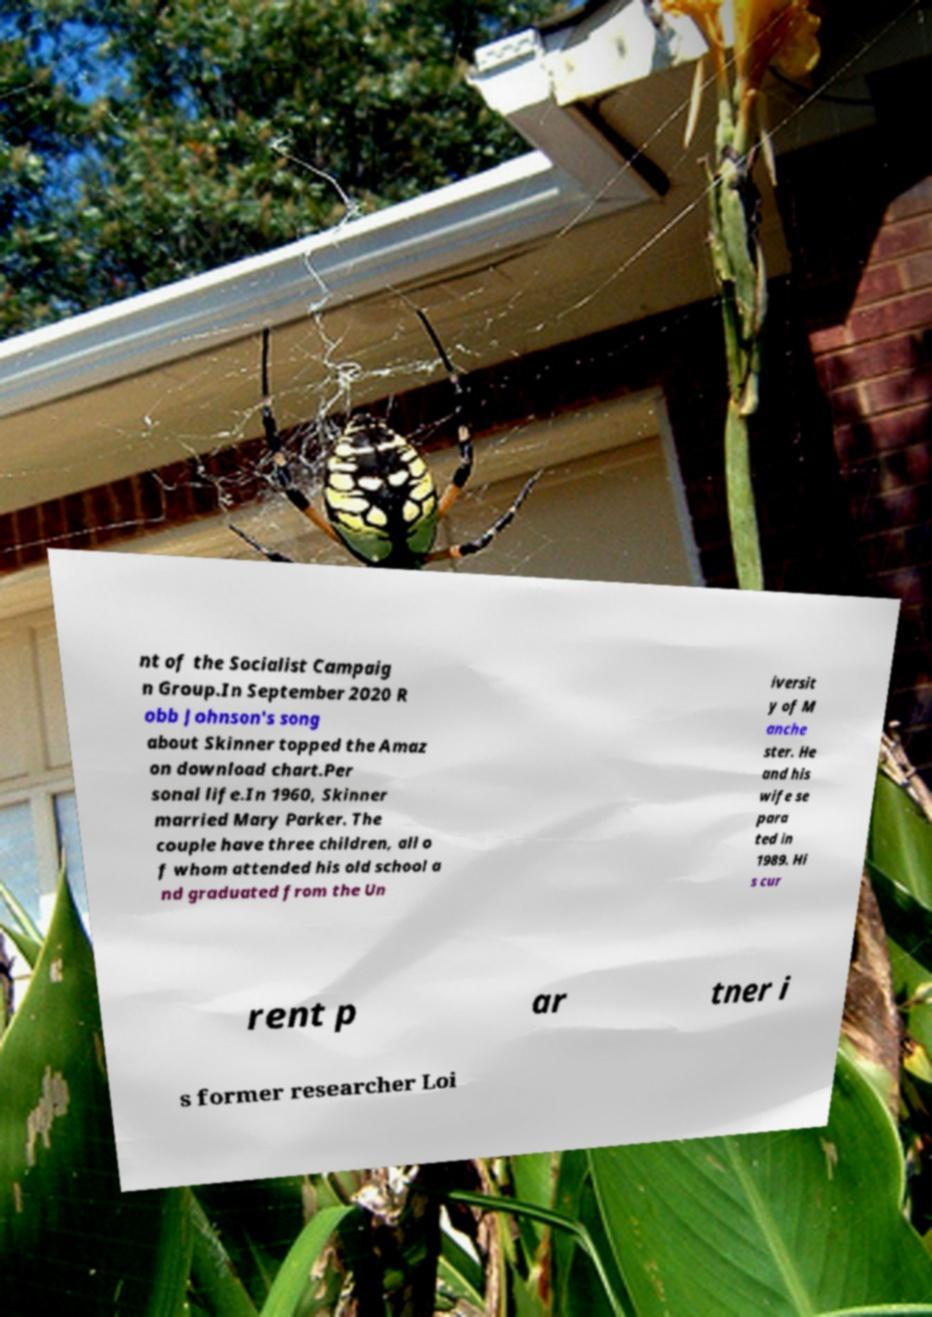There's text embedded in this image that I need extracted. Can you transcribe it verbatim? nt of the Socialist Campaig n Group.In September 2020 R obb Johnson's song about Skinner topped the Amaz on download chart.Per sonal life.In 1960, Skinner married Mary Parker. The couple have three children, all o f whom attended his old school a nd graduated from the Un iversit y of M anche ster. He and his wife se para ted in 1989. Hi s cur rent p ar tner i s former researcher Loi 